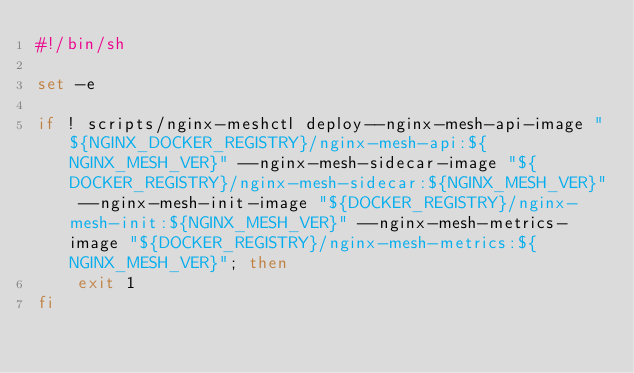Convert code to text. <code><loc_0><loc_0><loc_500><loc_500><_Bash_>#!/bin/sh

set -e

if ! scripts/nginx-meshctl deploy--nginx-mesh-api-image "${NGINX_DOCKER_REGISTRY}/nginx-mesh-api:${NGINX_MESH_VER}" --nginx-mesh-sidecar-image "${DOCKER_REGISTRY}/nginx-mesh-sidecar:${NGINX_MESH_VER}" --nginx-mesh-init-image "${DOCKER_REGISTRY}/nginx-mesh-init:${NGINX_MESH_VER}" --nginx-mesh-metrics-image "${DOCKER_REGISTRY}/nginx-mesh-metrics:${NGINX_MESH_VER}"; then
	exit 1
fi
</code> 